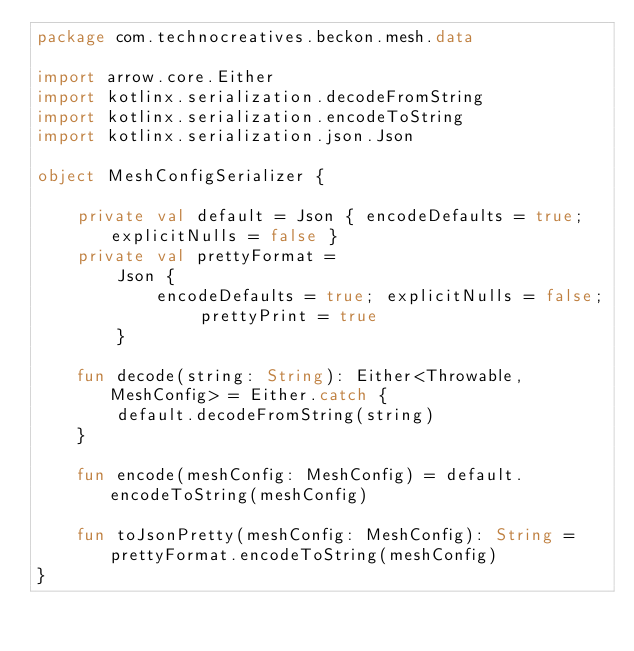<code> <loc_0><loc_0><loc_500><loc_500><_Kotlin_>package com.technocreatives.beckon.mesh.data

import arrow.core.Either
import kotlinx.serialization.decodeFromString
import kotlinx.serialization.encodeToString
import kotlinx.serialization.json.Json

object MeshConfigSerializer {

    private val default = Json { encodeDefaults = true; explicitNulls = false }
    private val prettyFormat =
        Json {
            encodeDefaults = true; explicitNulls = false; prettyPrint = true
        }

    fun decode(string: String): Either<Throwable, MeshConfig> = Either.catch {
        default.decodeFromString(string)
    }

    fun encode(meshConfig: MeshConfig) = default.encodeToString(meshConfig)

    fun toJsonPretty(meshConfig: MeshConfig): String = prettyFormat.encodeToString(meshConfig)
}
</code> 